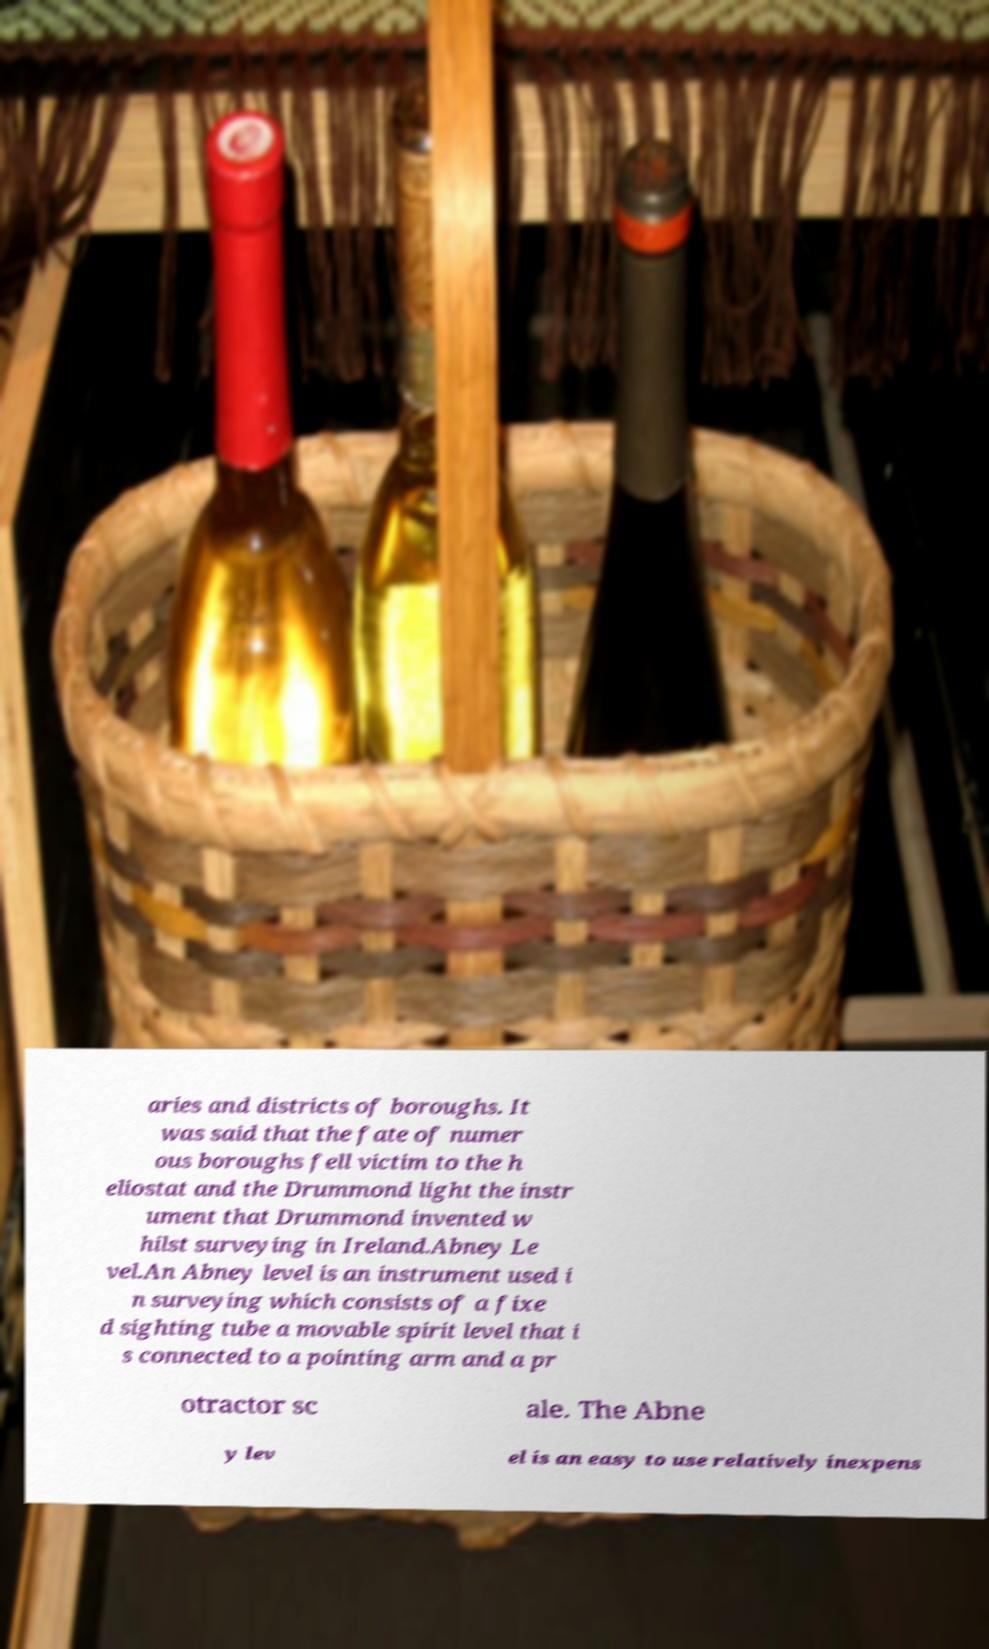Could you assist in decoding the text presented in this image and type it out clearly? aries and districts of boroughs. It was said that the fate of numer ous boroughs fell victim to the h eliostat and the Drummond light the instr ument that Drummond invented w hilst surveying in Ireland.Abney Le vel.An Abney level is an instrument used i n surveying which consists of a fixe d sighting tube a movable spirit level that i s connected to a pointing arm and a pr otractor sc ale. The Abne y lev el is an easy to use relatively inexpens 